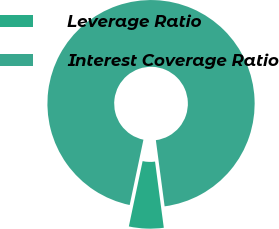Convert chart. <chart><loc_0><loc_0><loc_500><loc_500><pie_chart><fcel>Leverage Ratio<fcel>Interest Coverage Ratio<nl><fcel>5.4%<fcel>94.6%<nl></chart> 